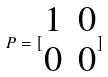Convert formula to latex. <formula><loc_0><loc_0><loc_500><loc_500>P = [ \begin{matrix} 1 & 0 \\ 0 & 0 \end{matrix} ]</formula> 